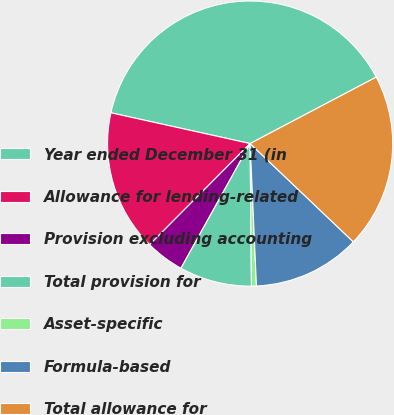<chart> <loc_0><loc_0><loc_500><loc_500><pie_chart><fcel>Year ended December 31 (in<fcel>Allowance for lending-related<fcel>Provision excluding accounting<fcel>Total provision for<fcel>Asset-specific<fcel>Formula-based<fcel>Total allowance for<nl><fcel>38.82%<fcel>16.01%<fcel>4.39%<fcel>8.21%<fcel>0.56%<fcel>12.18%<fcel>19.83%<nl></chart> 